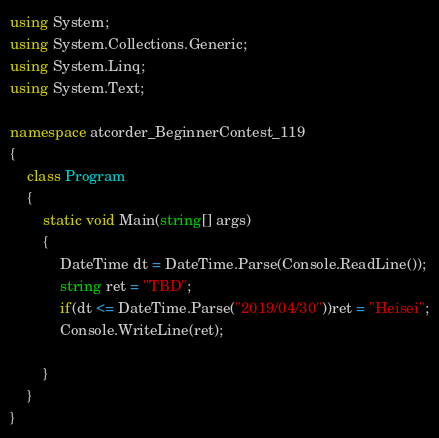Convert code to text. <code><loc_0><loc_0><loc_500><loc_500><_C#_>using System;
using System.Collections.Generic;
using System.Linq;
using System.Text;

namespace atcorder_BeginnerContest_119
{
    class Program
    {
        static void Main(string[] args)
        {
            DateTime dt = DateTime.Parse(Console.ReadLine());
            string ret = "TBD";
            if(dt <= DateTime.Parse("2019/04/30"))ret = "Heisei";
            Console.WriteLine(ret);

        }
    }
}
</code> 